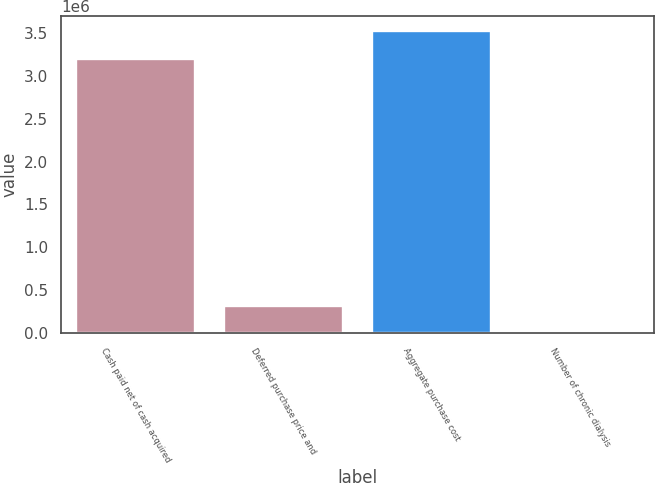Convert chart to OTSL. <chart><loc_0><loc_0><loc_500><loc_500><bar_chart><fcel>Cash paid net of cash acquired<fcel>Deferred purchase price and<fcel>Aggregate purchase cost<fcel>Number of chronic dialysis<nl><fcel>3.2024e+06<fcel>321722<fcel>3.52352e+06<fcel>609<nl></chart> 